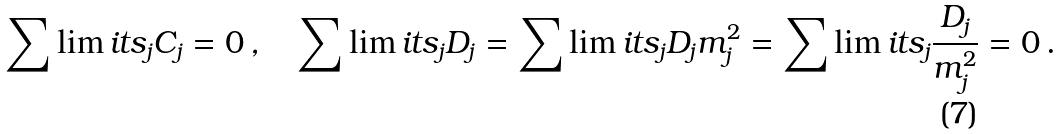<formula> <loc_0><loc_0><loc_500><loc_500>\sum \lim i t s _ { j } { C _ { j } } = 0 \, , \quad \sum \lim i t s _ { j } { D _ { j } } = \sum \lim i t s _ { j } { D _ { j } } { m _ { j } ^ { 2 } } = \sum \lim i t s _ { j } \frac { D _ { j } } { m _ { j } ^ { 2 } } = 0 \, .</formula> 